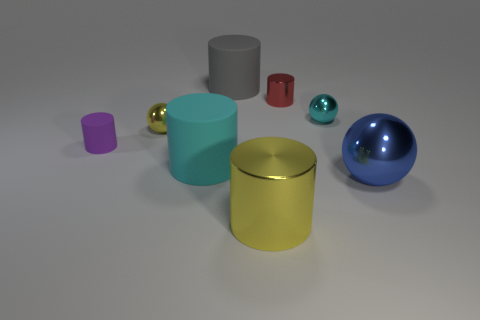Subtract all small balls. How many balls are left? 1 Add 1 tiny purple rubber cylinders. How many objects exist? 9 Subtract all blue balls. How many balls are left? 2 Subtract all cylinders. How many objects are left? 3 Subtract 3 cylinders. How many cylinders are left? 2 Add 1 large matte things. How many large matte things are left? 3 Add 2 yellow shiny cylinders. How many yellow shiny cylinders exist? 3 Subtract 0 red balls. How many objects are left? 8 Subtract all brown cylinders. Subtract all purple spheres. How many cylinders are left? 5 Subtract all cyan balls. How many gray cylinders are left? 1 